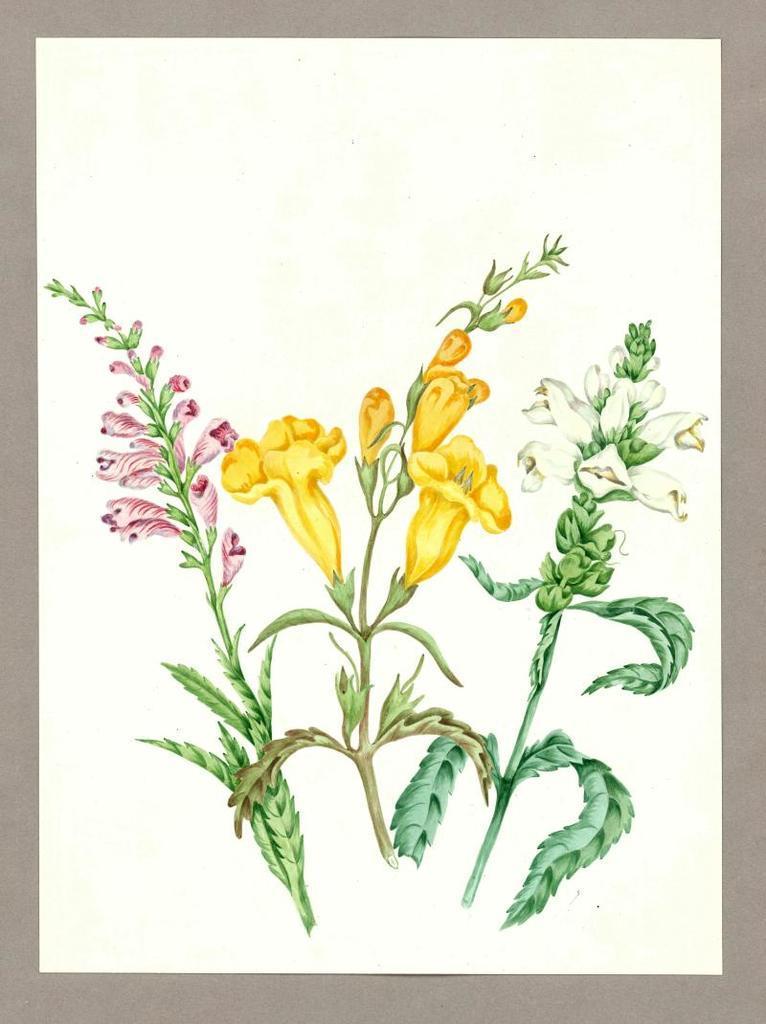Please provide a concise description of this image. This image consists of an art on the paper. There are three atoms with different types of flowers and green leaves. 